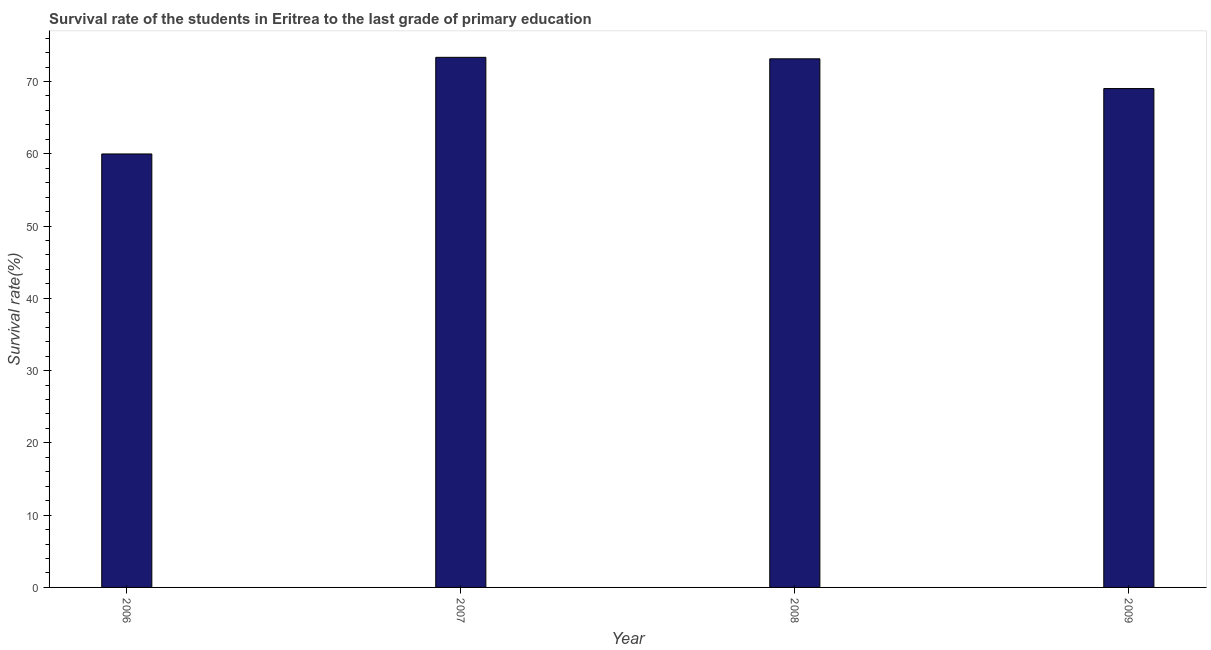Does the graph contain any zero values?
Provide a succinct answer. No. Does the graph contain grids?
Your answer should be compact. No. What is the title of the graph?
Give a very brief answer. Survival rate of the students in Eritrea to the last grade of primary education. What is the label or title of the Y-axis?
Your answer should be very brief. Survival rate(%). What is the survival rate in primary education in 2008?
Provide a short and direct response. 73.13. Across all years, what is the maximum survival rate in primary education?
Give a very brief answer. 73.34. Across all years, what is the minimum survival rate in primary education?
Give a very brief answer. 59.97. In which year was the survival rate in primary education maximum?
Your response must be concise. 2007. In which year was the survival rate in primary education minimum?
Offer a very short reply. 2006. What is the sum of the survival rate in primary education?
Offer a very short reply. 275.46. What is the difference between the survival rate in primary education in 2007 and 2009?
Provide a short and direct response. 4.32. What is the average survival rate in primary education per year?
Offer a very short reply. 68.86. What is the median survival rate in primary education?
Your answer should be very brief. 71.08. What is the ratio of the survival rate in primary education in 2006 to that in 2007?
Provide a short and direct response. 0.82. Is the survival rate in primary education in 2008 less than that in 2009?
Keep it short and to the point. No. What is the difference between the highest and the second highest survival rate in primary education?
Give a very brief answer. 0.21. Is the sum of the survival rate in primary education in 2008 and 2009 greater than the maximum survival rate in primary education across all years?
Keep it short and to the point. Yes. What is the difference between the highest and the lowest survival rate in primary education?
Ensure brevity in your answer.  13.37. How many years are there in the graph?
Provide a succinct answer. 4. What is the Survival rate(%) in 2006?
Provide a succinct answer. 59.97. What is the Survival rate(%) in 2007?
Provide a short and direct response. 73.34. What is the Survival rate(%) in 2008?
Keep it short and to the point. 73.13. What is the Survival rate(%) in 2009?
Provide a succinct answer. 69.02. What is the difference between the Survival rate(%) in 2006 and 2007?
Provide a succinct answer. -13.37. What is the difference between the Survival rate(%) in 2006 and 2008?
Make the answer very short. -13.16. What is the difference between the Survival rate(%) in 2006 and 2009?
Offer a terse response. -9.05. What is the difference between the Survival rate(%) in 2007 and 2008?
Offer a very short reply. 0.21. What is the difference between the Survival rate(%) in 2007 and 2009?
Keep it short and to the point. 4.32. What is the difference between the Survival rate(%) in 2008 and 2009?
Your answer should be compact. 4.11. What is the ratio of the Survival rate(%) in 2006 to that in 2007?
Keep it short and to the point. 0.82. What is the ratio of the Survival rate(%) in 2006 to that in 2008?
Ensure brevity in your answer.  0.82. What is the ratio of the Survival rate(%) in 2006 to that in 2009?
Ensure brevity in your answer.  0.87. What is the ratio of the Survival rate(%) in 2007 to that in 2009?
Keep it short and to the point. 1.06. What is the ratio of the Survival rate(%) in 2008 to that in 2009?
Give a very brief answer. 1.06. 